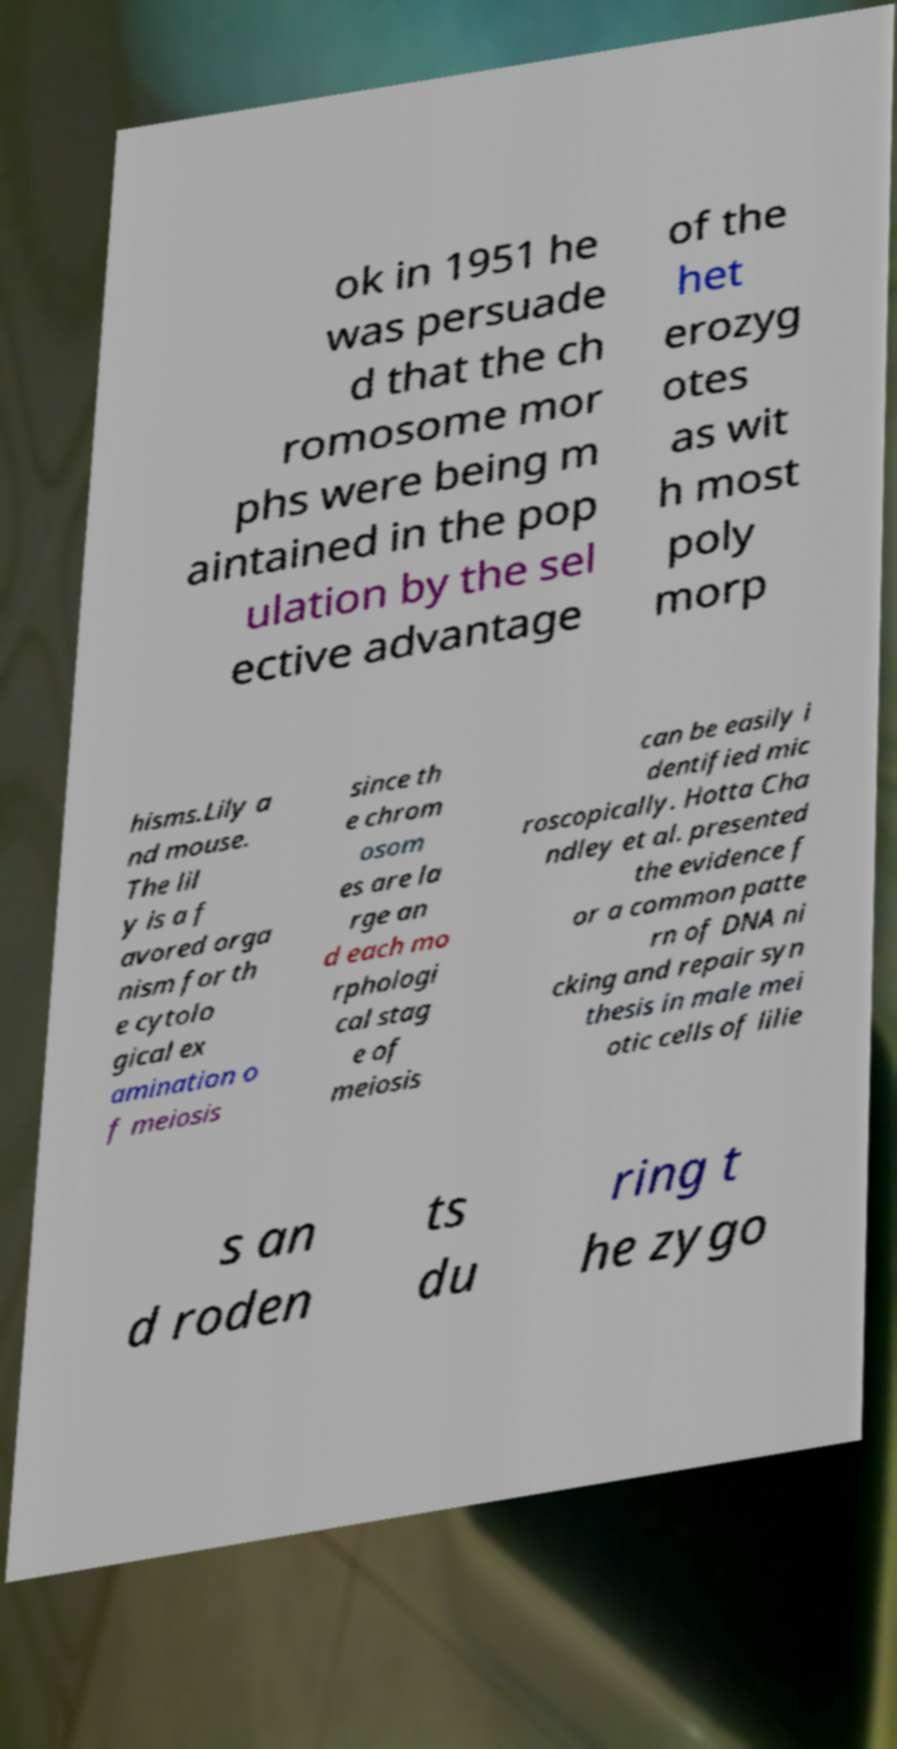Could you assist in decoding the text presented in this image and type it out clearly? ok in 1951 he was persuade d that the ch romosome mor phs were being m aintained in the pop ulation by the sel ective advantage of the het erozyg otes as wit h most poly morp hisms.Lily a nd mouse. The lil y is a f avored orga nism for th e cytolo gical ex amination o f meiosis since th e chrom osom es are la rge an d each mo rphologi cal stag e of meiosis can be easily i dentified mic roscopically. Hotta Cha ndley et al. presented the evidence f or a common patte rn of DNA ni cking and repair syn thesis in male mei otic cells of lilie s an d roden ts du ring t he zygo 